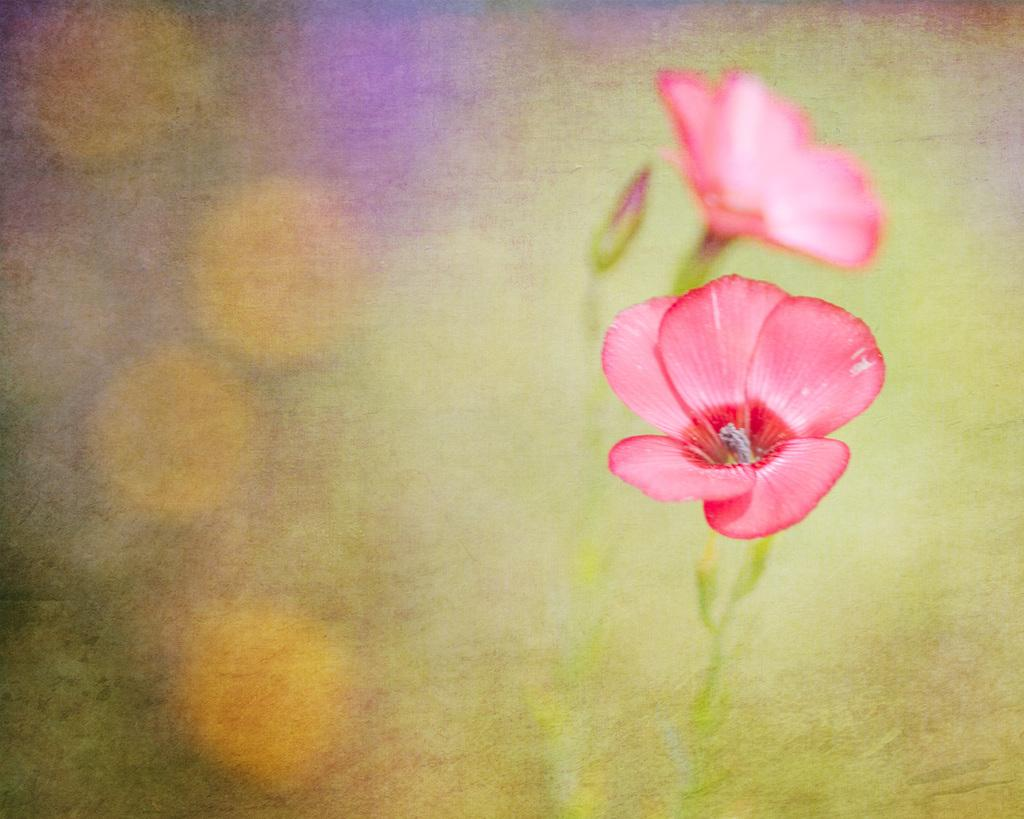What type of plants can be seen in the image? There are flowers and leaves in the image. What can be inferred about the focus of the image? The background of the image is blurry, which suggests that the flowers and leaves are the main focus. What type of school can be seen in the image? There is no school present in the image; it features flowers and leaves. Can you tell me how many bats are flying in the image? There are no bats present in the image; it features flowers and leaves. 